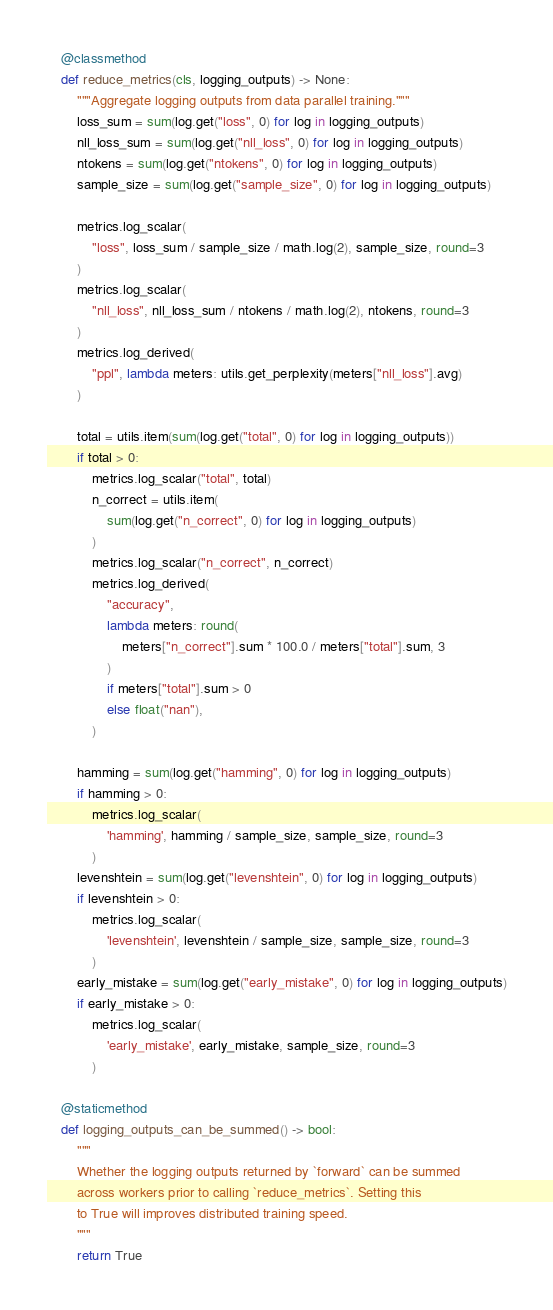Convert code to text. <code><loc_0><loc_0><loc_500><loc_500><_Python_>    @classmethod
    def reduce_metrics(cls, logging_outputs) -> None:
        """Aggregate logging outputs from data parallel training."""
        loss_sum = sum(log.get("loss", 0) for log in logging_outputs)
        nll_loss_sum = sum(log.get("nll_loss", 0) for log in logging_outputs)
        ntokens = sum(log.get("ntokens", 0) for log in logging_outputs)
        sample_size = sum(log.get("sample_size", 0) for log in logging_outputs)

        metrics.log_scalar(
            "loss", loss_sum / sample_size / math.log(2), sample_size, round=3
        )
        metrics.log_scalar(
            "nll_loss", nll_loss_sum / ntokens / math.log(2), ntokens, round=3
        )
        metrics.log_derived(
            "ppl", lambda meters: utils.get_perplexity(meters["nll_loss"].avg)
        )

        total = utils.item(sum(log.get("total", 0) for log in logging_outputs))
        if total > 0:
            metrics.log_scalar("total", total)
            n_correct = utils.item(
                sum(log.get("n_correct", 0) for log in logging_outputs)
            )
            metrics.log_scalar("n_correct", n_correct)
            metrics.log_derived(
                "accuracy",
                lambda meters: round(
                    meters["n_correct"].sum * 100.0 / meters["total"].sum, 3
                )
                if meters["total"].sum > 0
                else float("nan"),
            )

        hamming = sum(log.get("hamming", 0) for log in logging_outputs)
        if hamming > 0:
            metrics.log_scalar(
                'hamming', hamming / sample_size, sample_size, round=3
            )
        levenshtein = sum(log.get("levenshtein", 0) for log in logging_outputs)
        if levenshtein > 0:
            metrics.log_scalar(
                'levenshtein', levenshtein / sample_size, sample_size, round=3
            )
        early_mistake = sum(log.get("early_mistake", 0) for log in logging_outputs)
        if early_mistake > 0:
            metrics.log_scalar(
                'early_mistake', early_mistake, sample_size, round=3
            )

    @staticmethod
    def logging_outputs_can_be_summed() -> bool:
        """
        Whether the logging outputs returned by `forward` can be summed
        across workers prior to calling `reduce_metrics`. Setting this
        to True will improves distributed training speed.
        """
        return True
</code> 